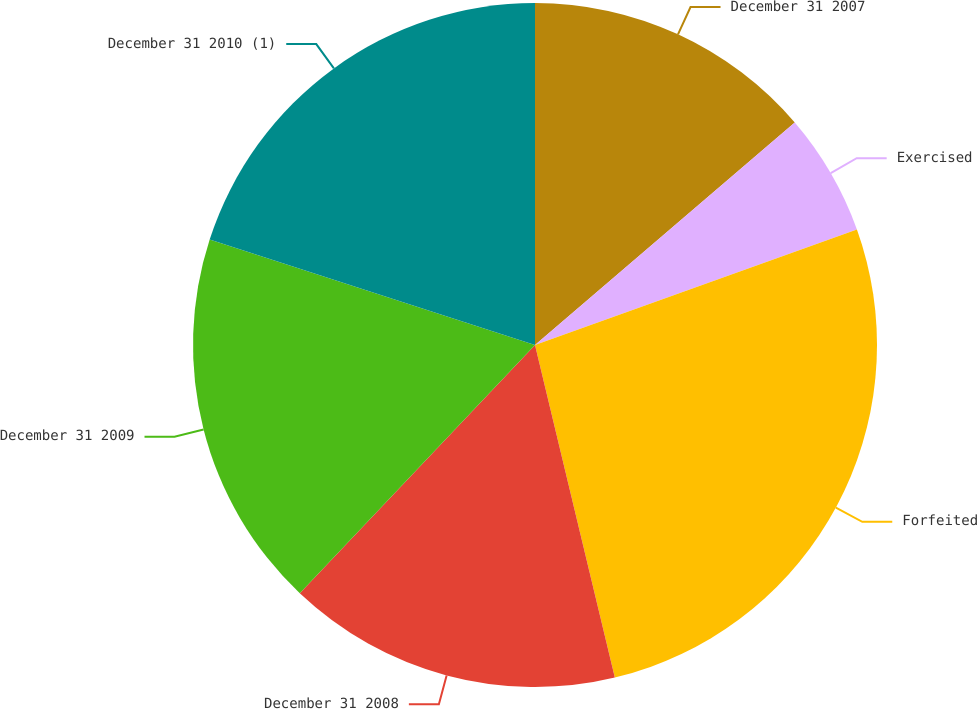Convert chart to OTSL. <chart><loc_0><loc_0><loc_500><loc_500><pie_chart><fcel>December 31 2007<fcel>Exercised<fcel>Forfeited<fcel>December 31 2008<fcel>December 31 2009<fcel>December 31 2010 (1)<nl><fcel>13.73%<fcel>5.79%<fcel>26.73%<fcel>15.82%<fcel>17.92%<fcel>20.01%<nl></chart> 